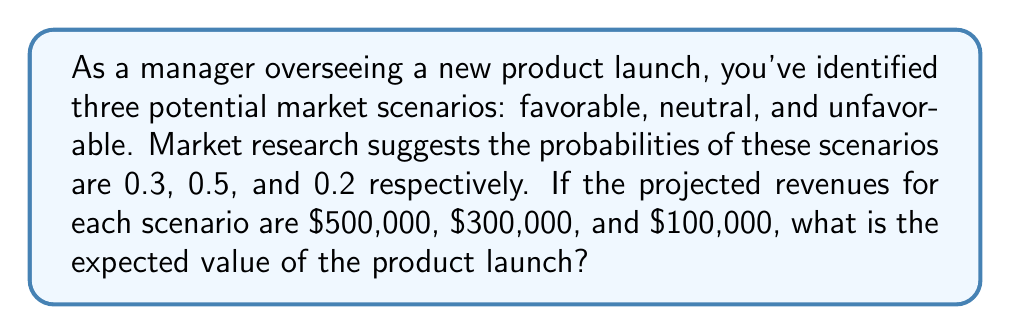Provide a solution to this math problem. To solve this problem, we'll use the concept of expected value for a discrete random variable. The expected value is calculated by multiplying each possible outcome by its probability and then summing these products.

Let's define our random variable X as the revenue from the product launch. We have:

1. P(favorable) = 0.3, X = $500,000
2. P(neutral) = 0.5, X = $300,000
3. P(unfavorable) = 0.2, X = $100,000

The formula for expected value is:

$$ E(X) = \sum_{i=1}^{n} x_i \cdot p(x_i) $$

Where $x_i$ are the possible values of X and $p(x_i)$ are their respective probabilities.

Applying this formula to our scenario:

$$ E(X) = 500,000 \cdot 0.3 + 300,000 \cdot 0.5 + 100,000 \cdot 0.2 $$

Let's calculate each term:

1. $500,000 \cdot 0.3 = 150,000$
2. $300,000 \cdot 0.5 = 150,000$
3. $100,000 \cdot 0.2 = 20,000$

Now, sum these values:

$$ E(X) = 150,000 + 150,000 + 20,000 = 320,000 $$

Therefore, the expected value of the product launch is $320,000.
Answer: $320,000 